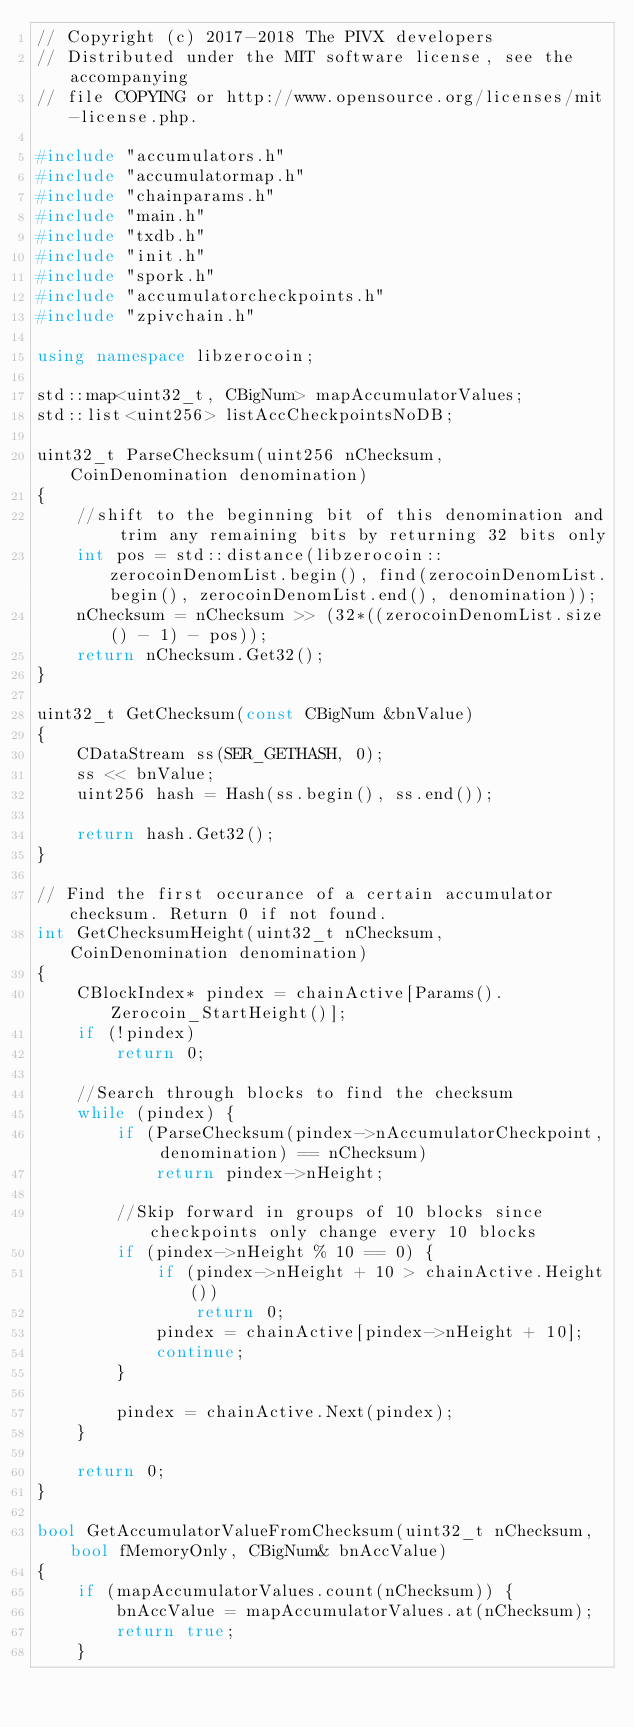Convert code to text. <code><loc_0><loc_0><loc_500><loc_500><_C++_>// Copyright (c) 2017-2018 The PIVX developers
// Distributed under the MIT software license, see the accompanying
// file COPYING or http://www.opensource.org/licenses/mit-license.php.

#include "accumulators.h"
#include "accumulatormap.h"
#include "chainparams.h"
#include "main.h"
#include "txdb.h"
#include "init.h"
#include "spork.h"
#include "accumulatorcheckpoints.h"
#include "zpivchain.h"

using namespace libzerocoin;

std::map<uint32_t, CBigNum> mapAccumulatorValues;
std::list<uint256> listAccCheckpointsNoDB;

uint32_t ParseChecksum(uint256 nChecksum, CoinDenomination denomination)
{
    //shift to the beginning bit of this denomination and trim any remaining bits by returning 32 bits only
    int pos = std::distance(libzerocoin::zerocoinDenomList.begin(), find(zerocoinDenomList.begin(), zerocoinDenomList.end(), denomination));
    nChecksum = nChecksum >> (32*((zerocoinDenomList.size() - 1) - pos));
    return nChecksum.Get32();
}

uint32_t GetChecksum(const CBigNum &bnValue)
{
    CDataStream ss(SER_GETHASH, 0);
    ss << bnValue;
    uint256 hash = Hash(ss.begin(), ss.end());

    return hash.Get32();
}

// Find the first occurance of a certain accumulator checksum. Return 0 if not found.
int GetChecksumHeight(uint32_t nChecksum, CoinDenomination denomination)
{
    CBlockIndex* pindex = chainActive[Params().Zerocoin_StartHeight()];
    if (!pindex)
        return 0;

    //Search through blocks to find the checksum
    while (pindex) {
        if (ParseChecksum(pindex->nAccumulatorCheckpoint, denomination) == nChecksum)
            return pindex->nHeight;

        //Skip forward in groups of 10 blocks since checkpoints only change every 10 blocks
        if (pindex->nHeight % 10 == 0) {
            if (pindex->nHeight + 10 > chainActive.Height())
                return 0;
            pindex = chainActive[pindex->nHeight + 10];
            continue;
        }

        pindex = chainActive.Next(pindex);
    }

    return 0;
}

bool GetAccumulatorValueFromChecksum(uint32_t nChecksum, bool fMemoryOnly, CBigNum& bnAccValue)
{
    if (mapAccumulatorValues.count(nChecksum)) {
        bnAccValue = mapAccumulatorValues.at(nChecksum);
        return true;
    }
</code> 